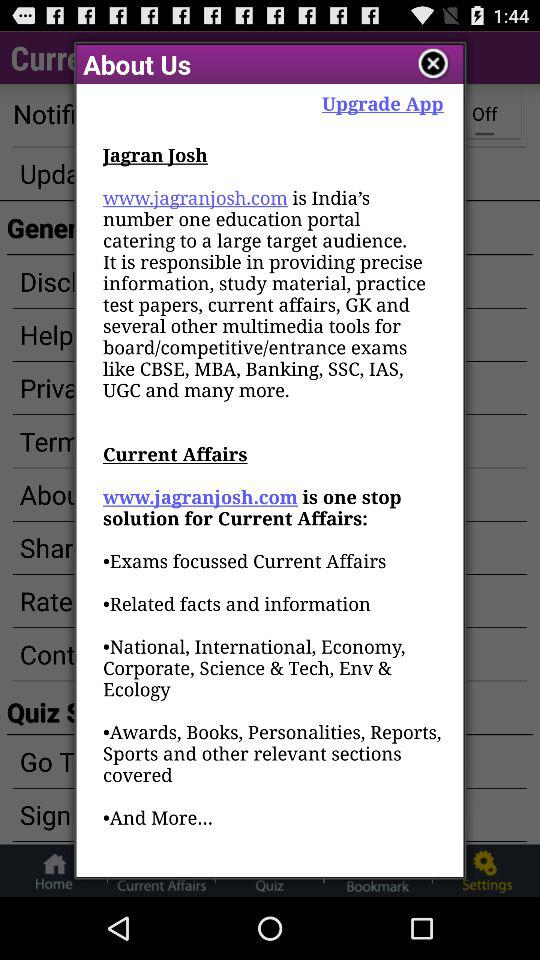What is jagaran josh?
When the provided information is insufficient, respond with <no answer>. <no answer> 